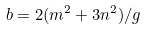Convert formula to latex. <formula><loc_0><loc_0><loc_500><loc_500>b = 2 ( m ^ { 2 } + 3 n ^ { 2 } ) / g</formula> 